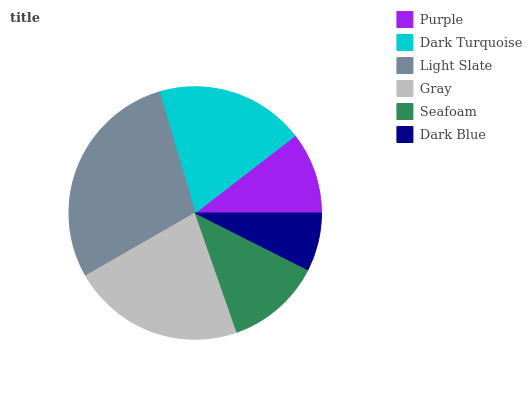Is Dark Blue the minimum?
Answer yes or no. Yes. Is Light Slate the maximum?
Answer yes or no. Yes. Is Dark Turquoise the minimum?
Answer yes or no. No. Is Dark Turquoise the maximum?
Answer yes or no. No. Is Dark Turquoise greater than Purple?
Answer yes or no. Yes. Is Purple less than Dark Turquoise?
Answer yes or no. Yes. Is Purple greater than Dark Turquoise?
Answer yes or no. No. Is Dark Turquoise less than Purple?
Answer yes or no. No. Is Dark Turquoise the high median?
Answer yes or no. Yes. Is Seafoam the low median?
Answer yes or no. Yes. Is Gray the high median?
Answer yes or no. No. Is Purple the low median?
Answer yes or no. No. 